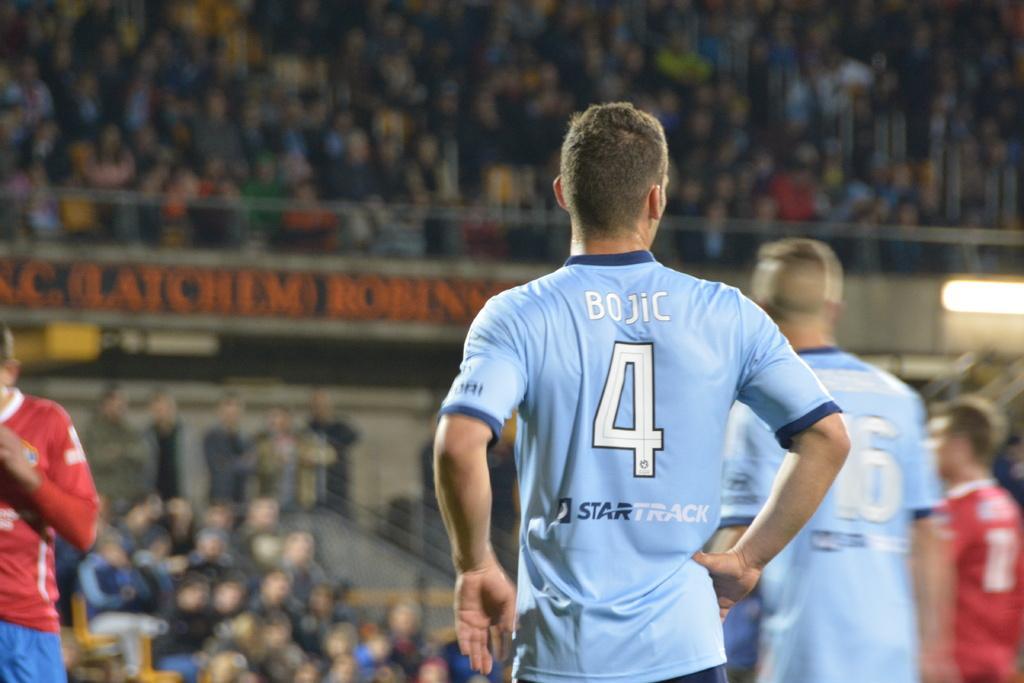Please provide a concise description of this image. In this image I can see the group of people with blue and red color dresses. In the background I can see the boards, lights, railing and many people. But the background is blurred. 